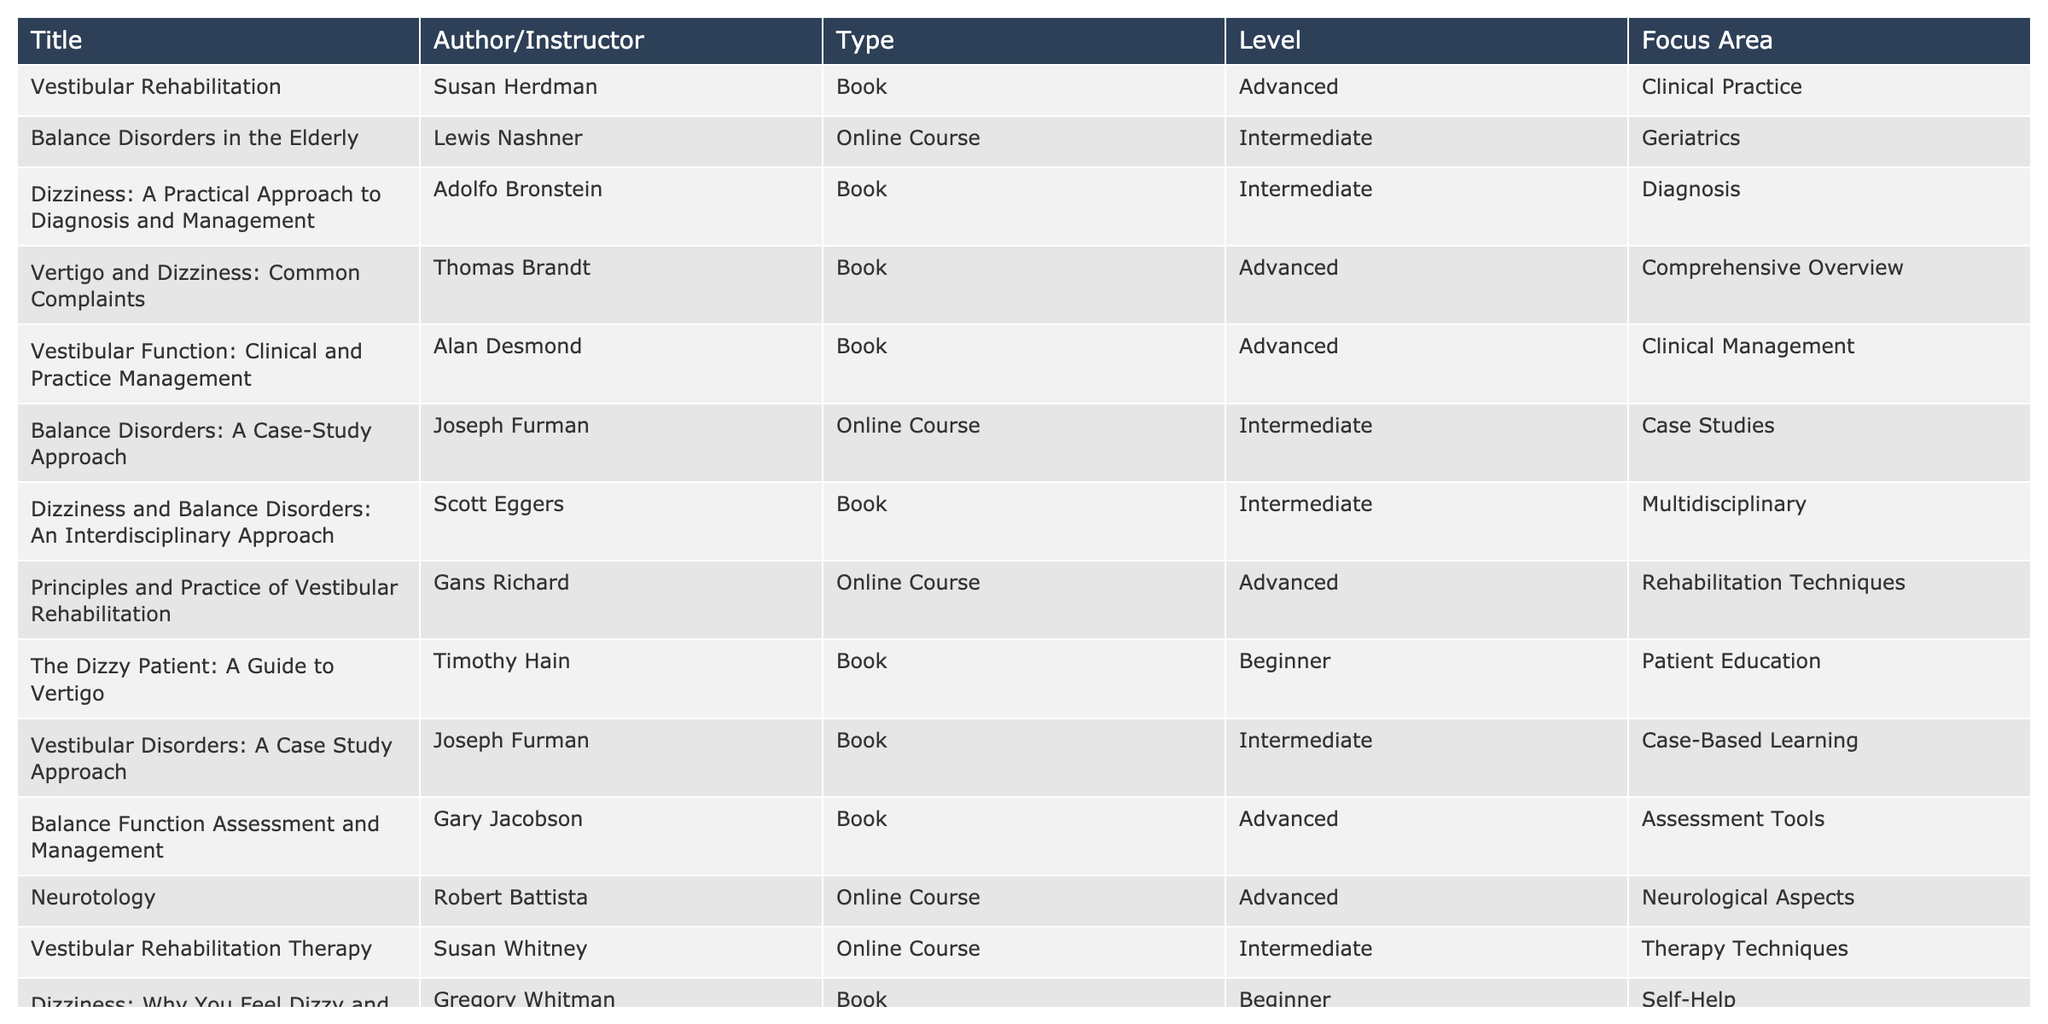What type of resource is "Dizziness: A Practical Approach to Diagnosis and Management"? Referring to the table, we can see the "Type" column corresponding to "Dizziness: A Practical Approach to Diagnosis and Management" lists it as a "Book".
Answer: Book Who is the author of "Balance Disorders in the Elderly"? Looking at the "Author/Instructor" column, the name listed next to "Balance Disorders in the Elderly" is Lewis Nashner.
Answer: Lewis Nashner How many advanced-level resources are listed in the table? To determine the number of advanced-level resources, we can filter the "Level" column and count the entries labeled "Advanced". There are 6 such entries: "Vestibular Rehabilitation", "Vertigo and Dizziness: Common Complaints", "Vestibular Function: Clinical and Practice Management", "Balance Function Assessment and Management", "Neurotology", and "Vestibular Disorders: Evidence and Practice for Physiotherapists".
Answer: 6 Is "Principles and Practice of Vestibular Rehabilitation" an online course? Checking the "Type" column for "Principles and Practice of Vestibular Rehabilitation", it indicates that it is indeed an "Online Course".
Answer: Yes Which focus area has the most resources listed and how many are there? We analyze the "Focus Area" column and count occurrences: "Clinical Management" appears once, "Diagnosis" appears once, "Comprehensive Overview" appears once, "Neurological Aspects" appears once, "Multidisciplinary" appears once, "Patient Education" appears once, "Self-Help" appears once, and "Rehabilitation Techniques" appears twice. The "Clinical Practice" and "Evidence-Based Practice" each appears once as well. The focus area with the most entries is "Case Studies" from "Balance Disorders: A Case-Study Approach" which appears twice.
Answer: Case Studies, 2 